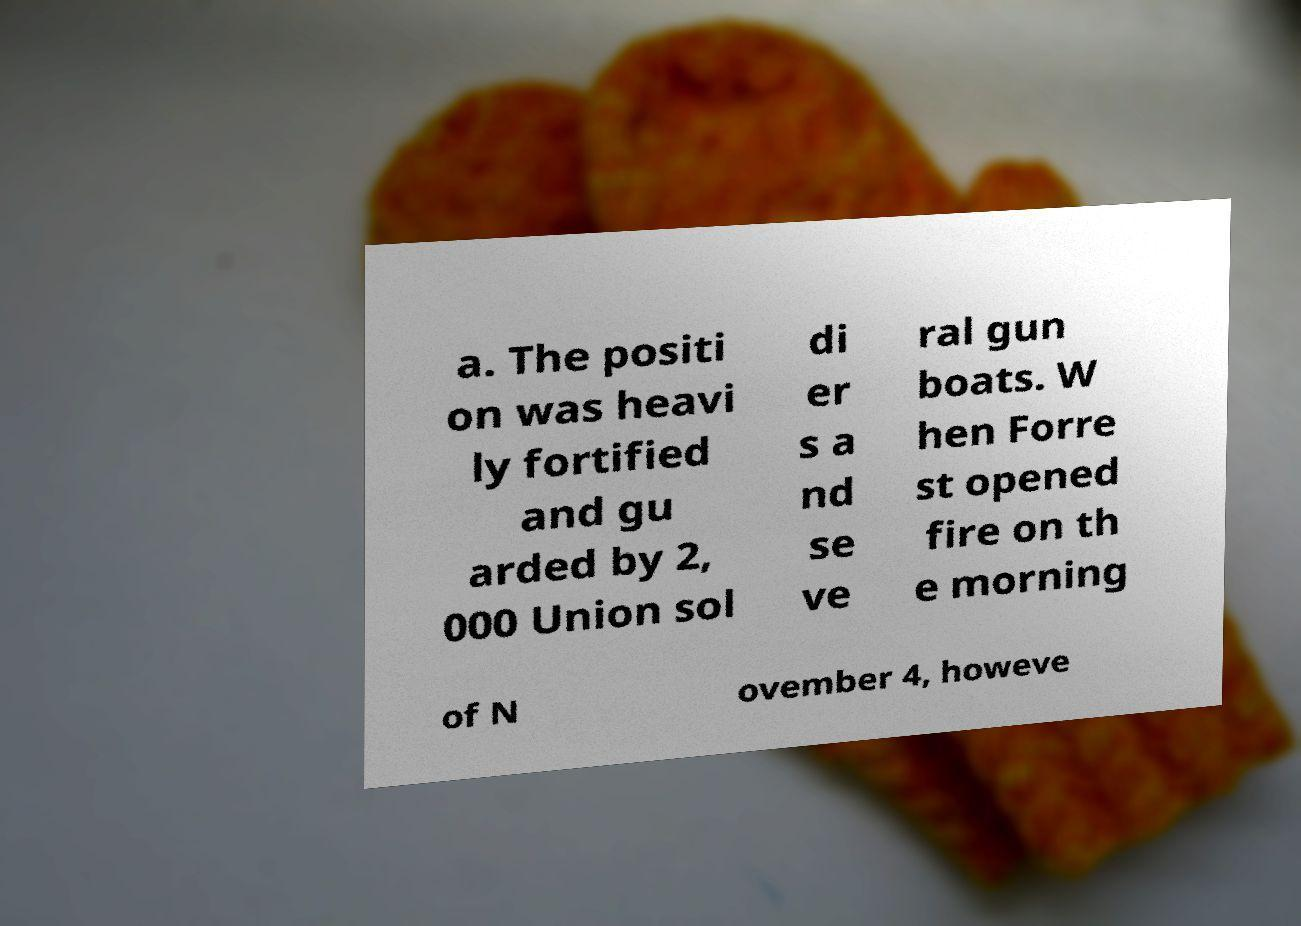Could you extract and type out the text from this image? a. The positi on was heavi ly fortified and gu arded by 2, 000 Union sol di er s a nd se ve ral gun boats. W hen Forre st opened fire on th e morning of N ovember 4, howeve 